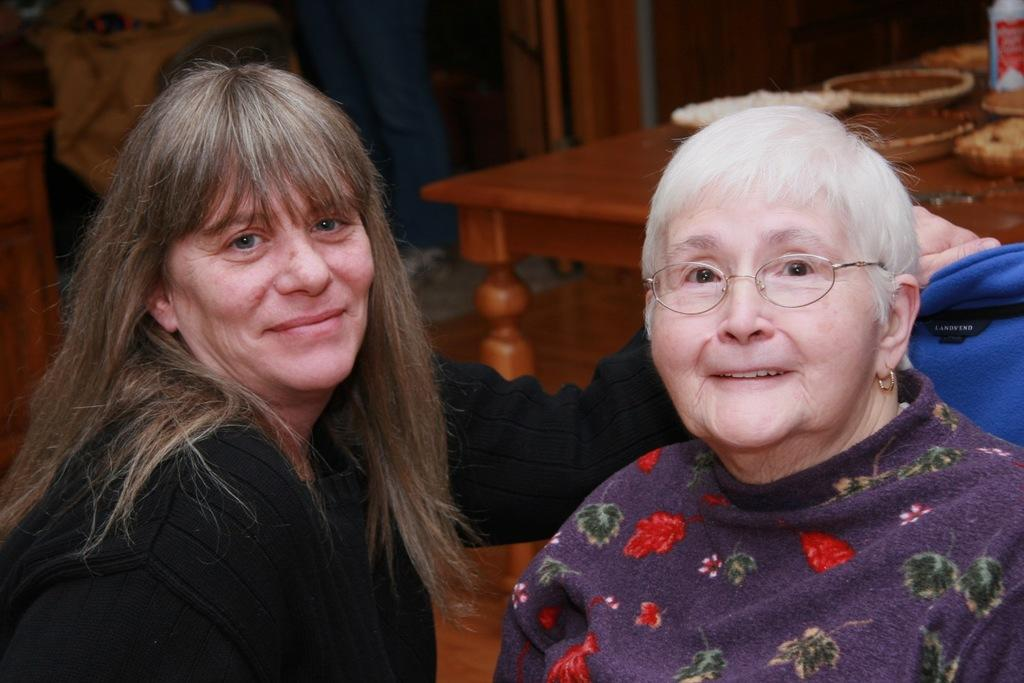How many people are in the image? There are two people in the image. What are the people doing in the image? The people are standing near a car and holding balloons. What is the background of the image? There is a road and trees in the background of the image. What type of jam is being spread on the toast in the image? There is no toast or jam present in the image; it features a group of people standing near a car and holding balloons. 